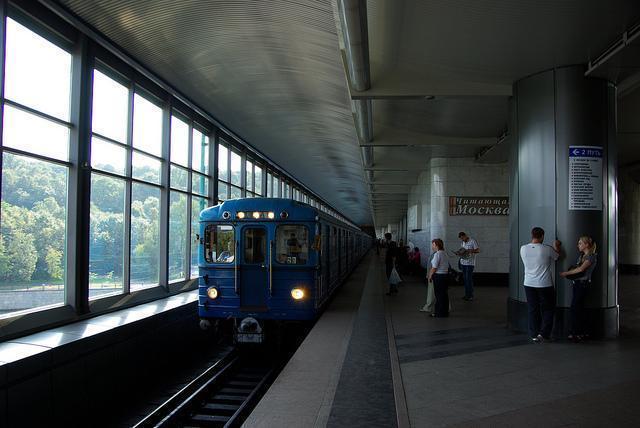What country is this location?
Choose the correct response and explain in the format: 'Answer: answer
Rationale: rationale.'
Options: Russia, moldova, ukraine, belarus. Answer: russia.
Rationale: The train looks to be in russia. 